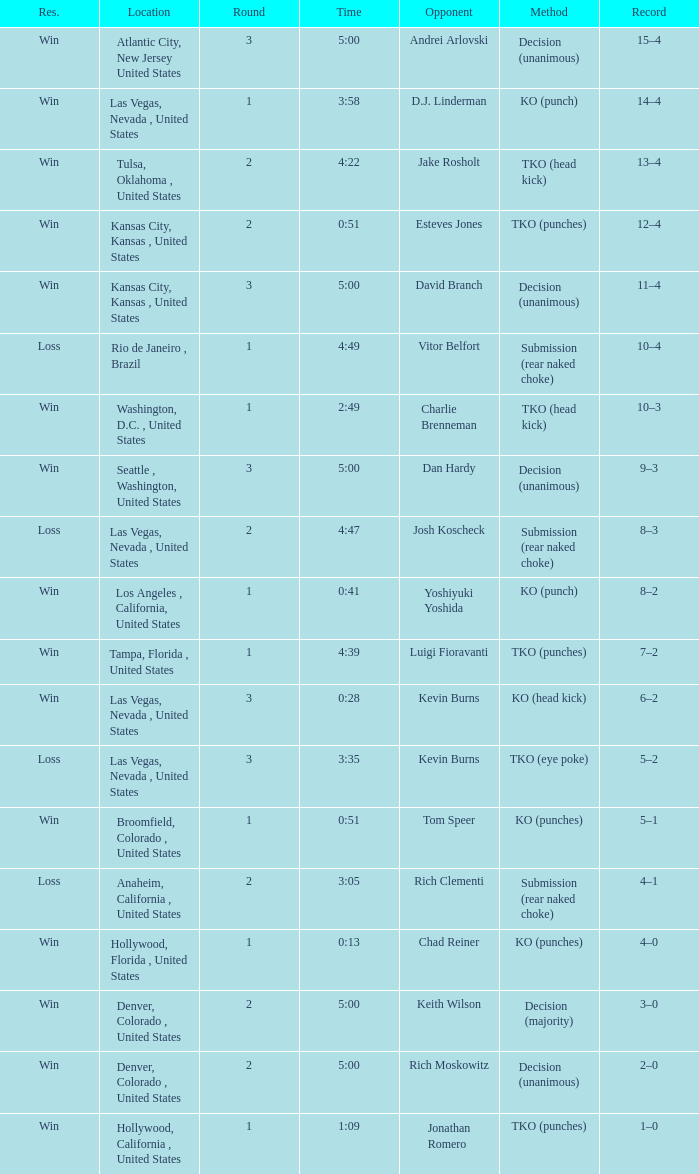What is the highest round number with a time of 4:39? 1.0. 